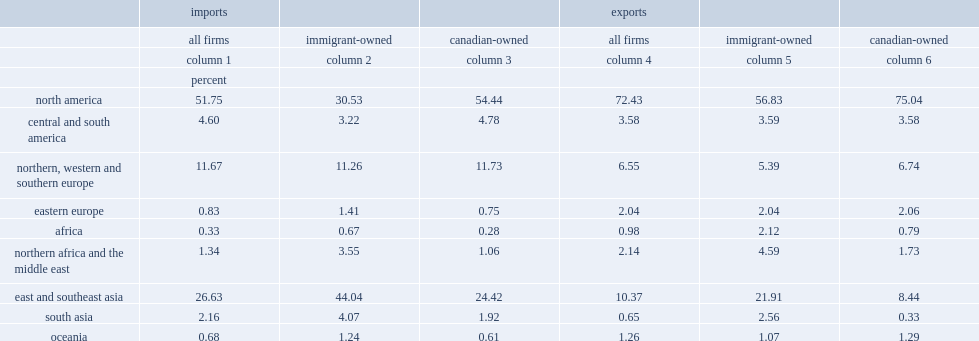What percentage of imports are skewed toward north america accounting for? 51.75. What percentage of emports are skewed toward north america accounting for? 72.43. What percentage of imports with the second most important trading partner region-east and southeast asia? 26.63. What percentage of exports with the second most important trading partner region-east and southeast asia? 10.37. What percentage of imports trade activities among immigrant-owned firms observed to be less concentrated in north america? 30.53. What percentage of exports trade activities among immigrant-owned firms observed to be less concentrated in north america? 56.83. 